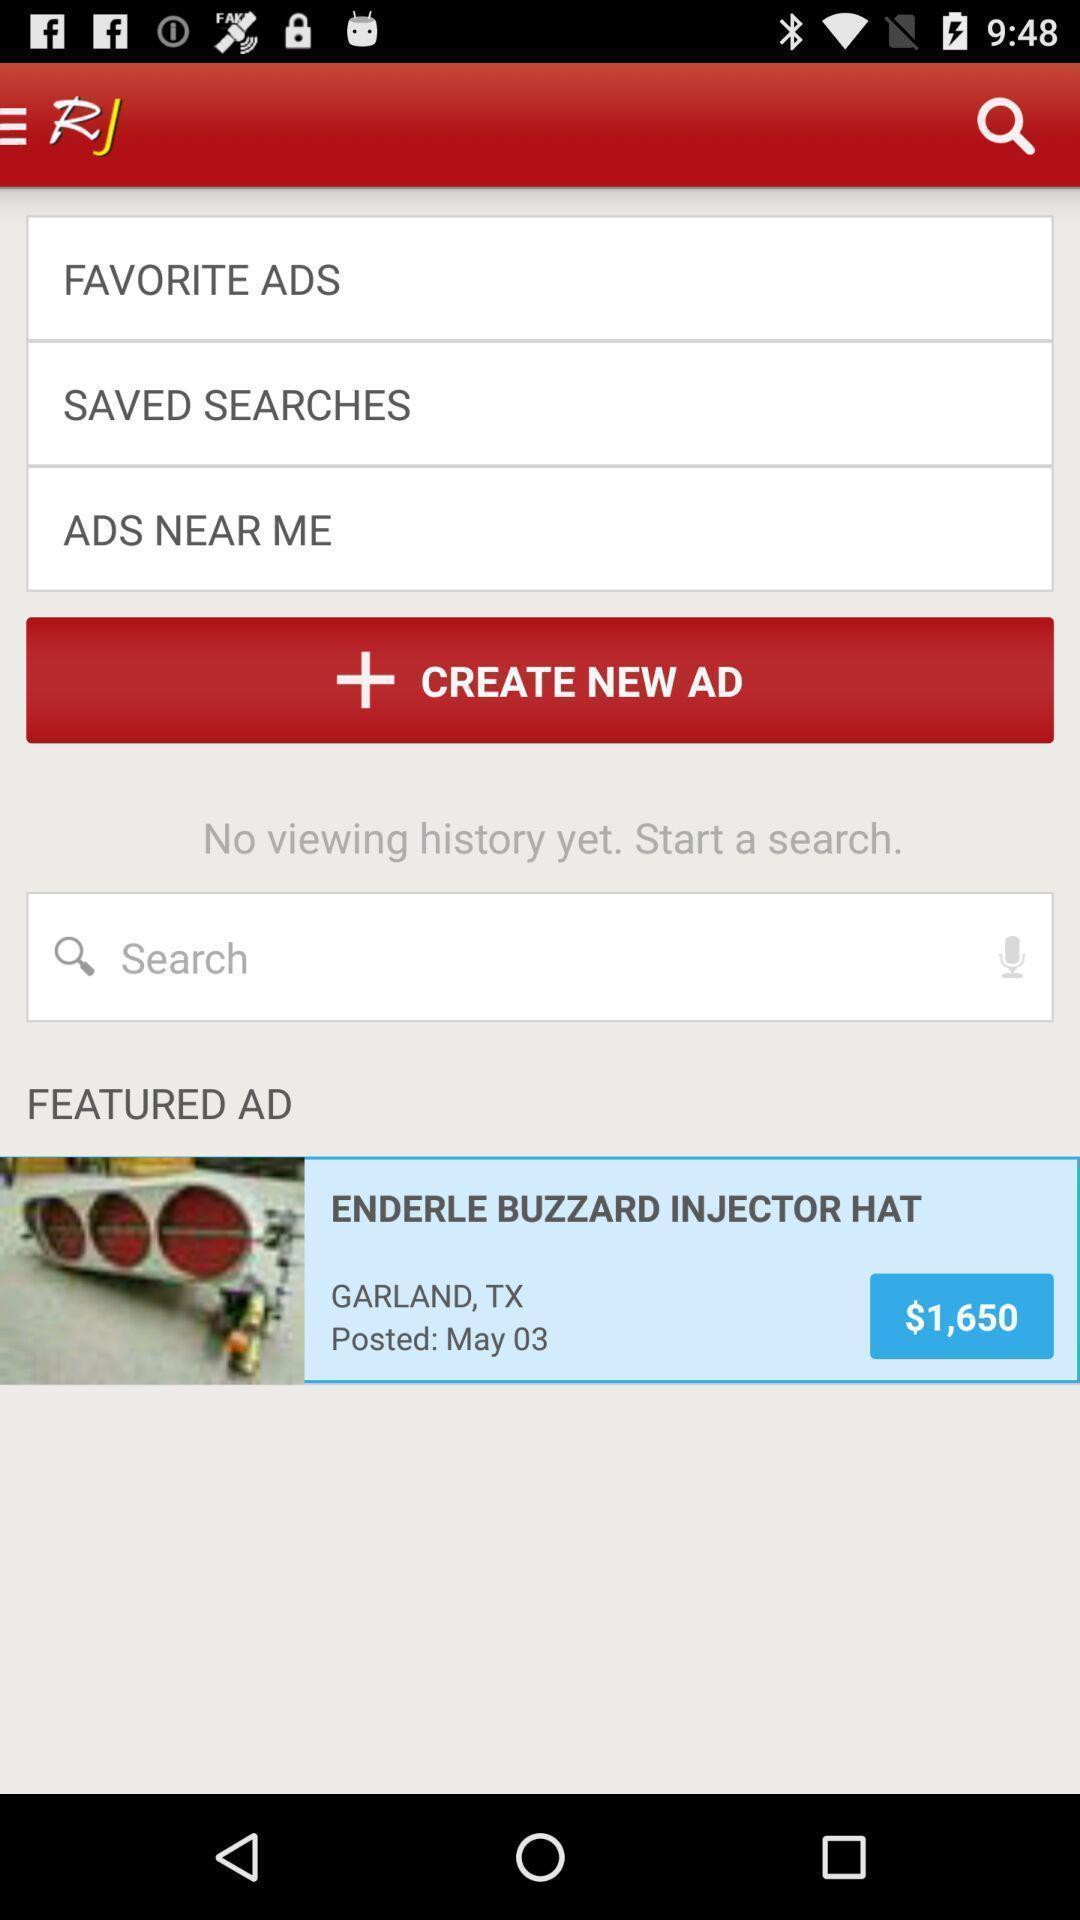Describe the visual elements of this screenshot. Screen shows to create new ad. 